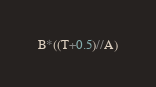Convert code to text. <code><loc_0><loc_0><loc_500><loc_500><_Python_>B*((T+0.5)//A)</code> 